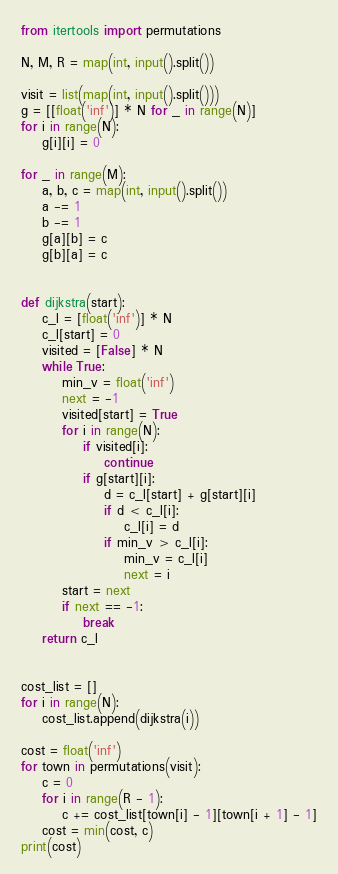Convert code to text. <code><loc_0><loc_0><loc_500><loc_500><_Python_>from itertools import permutations

N, M, R = map(int, input().split())

visit = list(map(int, input().split()))
g = [[float('inf')] * N for _ in range(N)]
for i in range(N):
    g[i][i] = 0

for _ in range(M):
    a, b, c = map(int, input().split())
    a -= 1
    b -= 1
    g[a][b] = c
    g[b][a] = c


def dijkstra(start):
    c_l = [float('inf')] * N
    c_l[start] = 0
    visited = [False] * N
    while True:
        min_v = float('inf')
        next = -1
        visited[start] = True
        for i in range(N):
            if visited[i]:
                continue
            if g[start][i]:
                d = c_l[start] + g[start][i]
                if d < c_l[i]:
                    c_l[i] = d
                if min_v > c_l[i]:
                    min_v = c_l[i]
                    next = i
        start = next
        if next == -1:
            break
    return c_l


cost_list = []
for i in range(N):
    cost_list.append(dijkstra(i))

cost = float('inf')
for town in permutations(visit):
    c = 0
    for i in range(R - 1):
        c += cost_list[town[i] - 1][town[i + 1] - 1]
    cost = min(cost, c)
print(cost)
</code> 